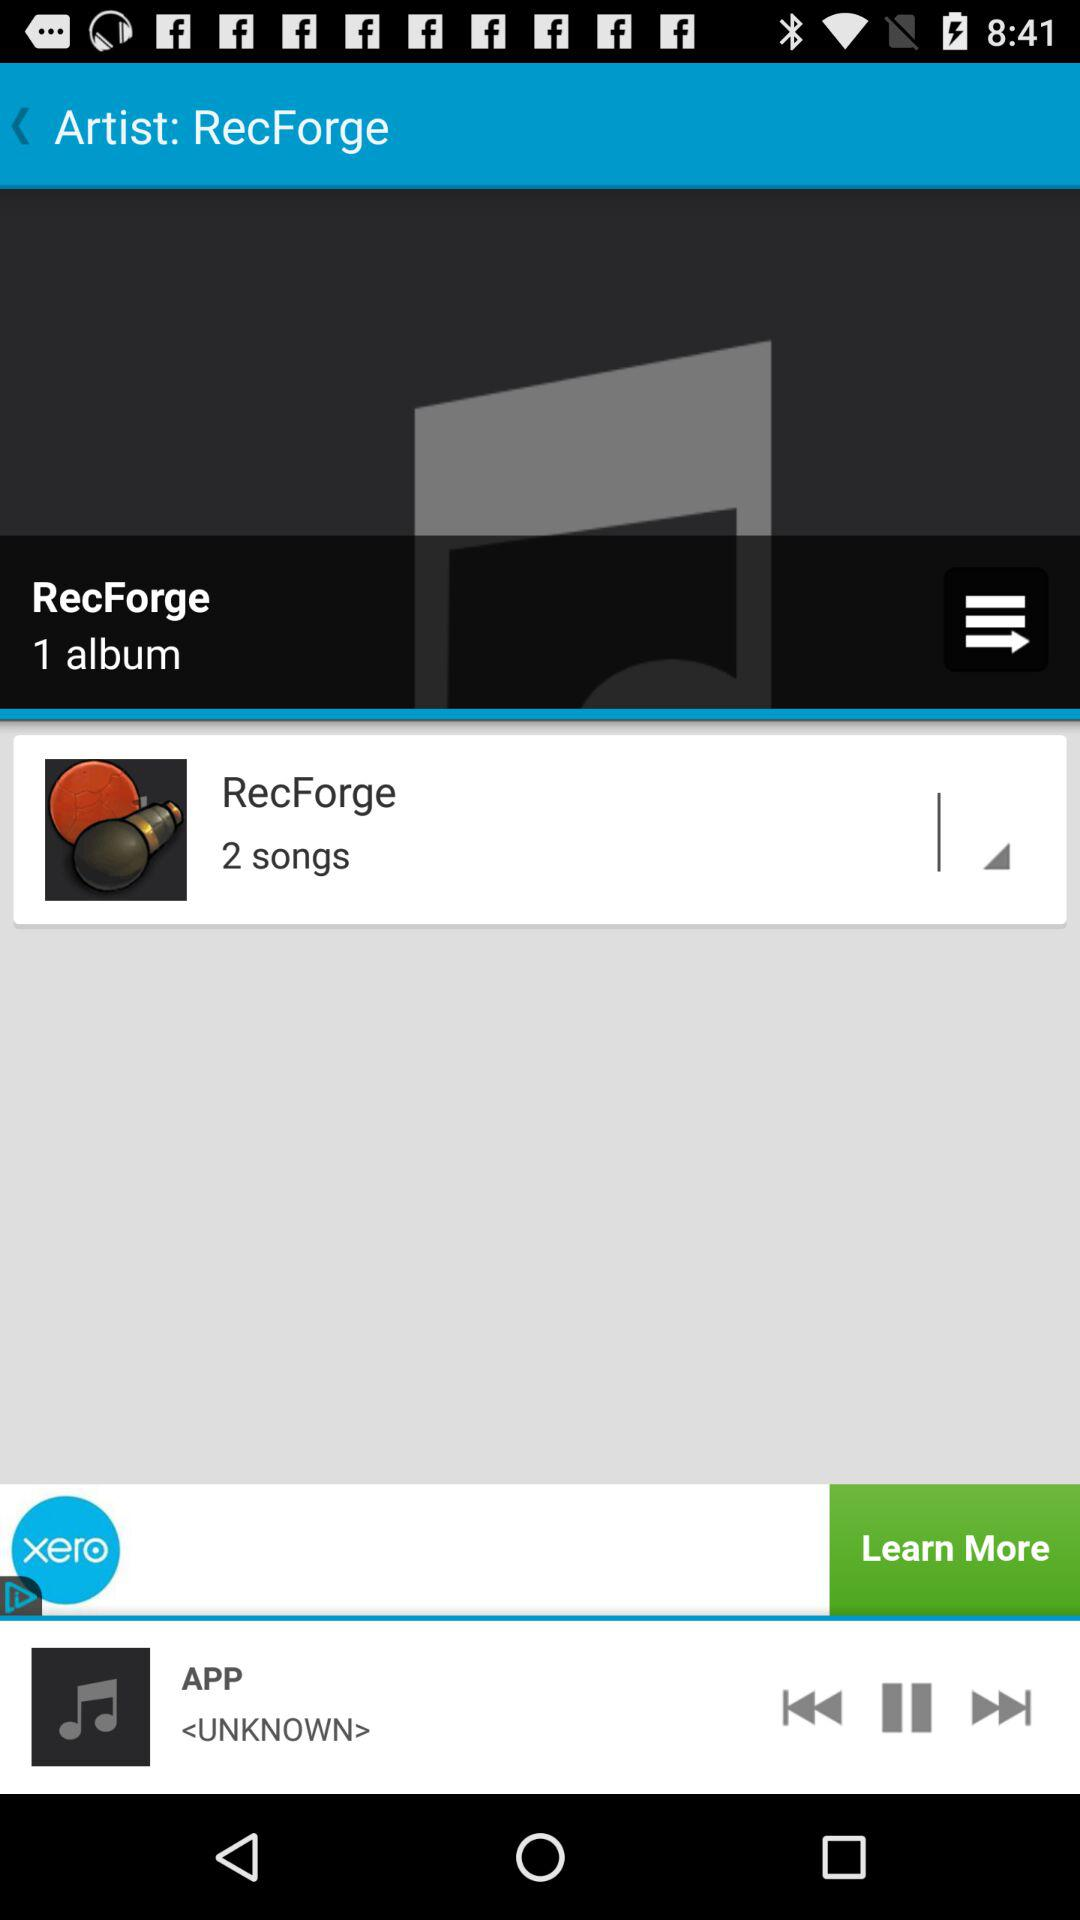How many albums are there in "RecForge"? There is 1 album in "RecForge". 